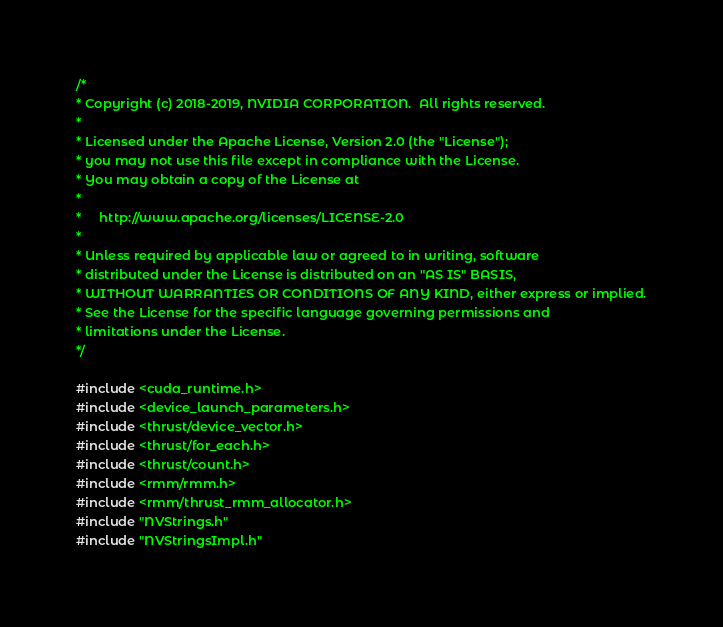<code> <loc_0><loc_0><loc_500><loc_500><_Cuda_>/*
* Copyright (c) 2018-2019, NVIDIA CORPORATION.  All rights reserved.
*
* Licensed under the Apache License, Version 2.0 (the "License");
* you may not use this file except in compliance with the License.
* You may obtain a copy of the License at
*
*     http://www.apache.org/licenses/LICENSE-2.0
*
* Unless required by applicable law or agreed to in writing, software
* distributed under the License is distributed on an "AS IS" BASIS,
* WITHOUT WARRANTIES OR CONDITIONS OF ANY KIND, either express or implied.
* See the License for the specific language governing permissions and
* limitations under the License.
*/

#include <cuda_runtime.h>
#include <device_launch_parameters.h>
#include <thrust/device_vector.h>
#include <thrust/for_each.h>
#include <thrust/count.h>
#include <rmm/rmm.h>
#include <rmm/thrust_rmm_allocator.h>
#include "NVStrings.h"
#include "NVStringsImpl.h"</code> 